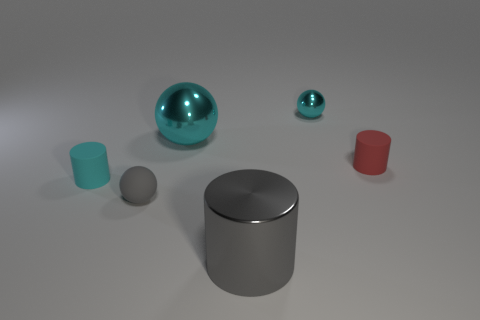What number of tiny matte cylinders are right of the small cyan sphere? There is 1 tiny matte cylinder positioned to the right of the small cyan sphere when viewing the scene from the current perspective. 